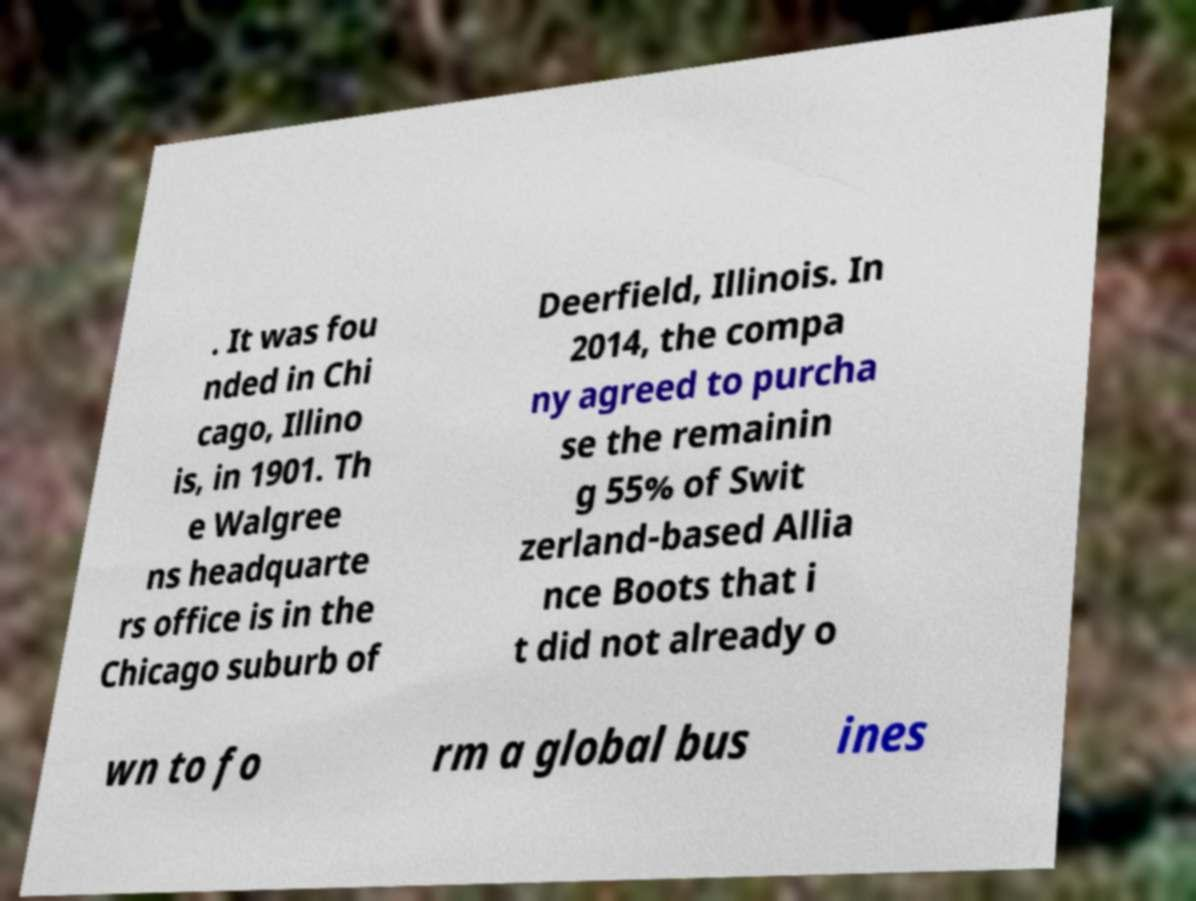Can you read and provide the text displayed in the image?This photo seems to have some interesting text. Can you extract and type it out for me? . It was fou nded in Chi cago, Illino is, in 1901. Th e Walgree ns headquarte rs office is in the Chicago suburb of Deerfield, Illinois. In 2014, the compa ny agreed to purcha se the remainin g 55% of Swit zerland-based Allia nce Boots that i t did not already o wn to fo rm a global bus ines 